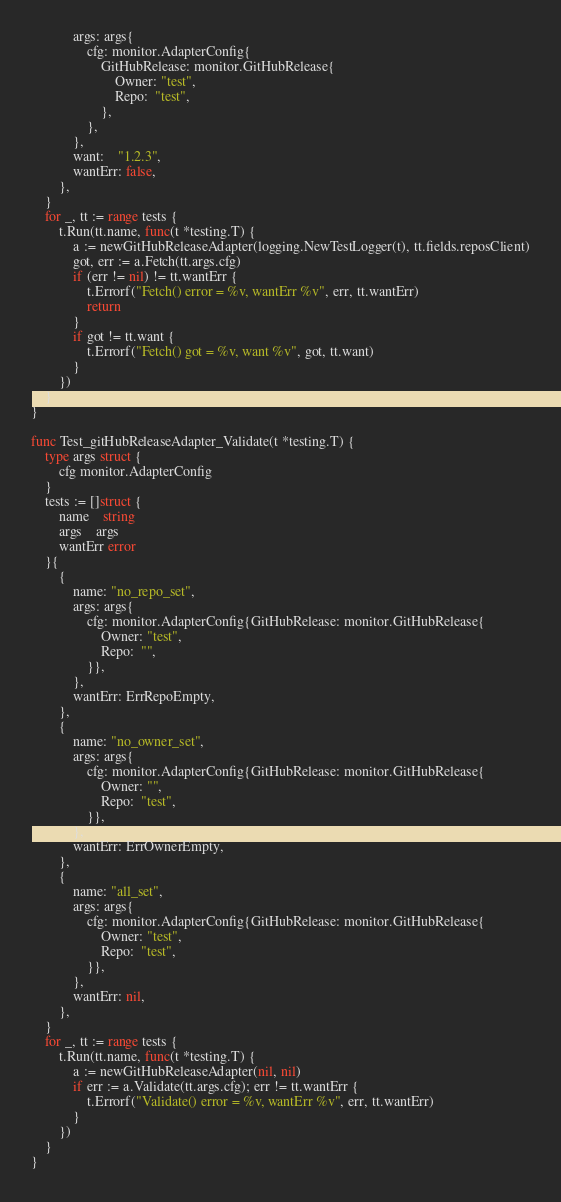<code> <loc_0><loc_0><loc_500><loc_500><_Go_>			args: args{
				cfg: monitor.AdapterConfig{
					GitHubRelease: monitor.GitHubRelease{
						Owner: "test",
						Repo:  "test",
					},
				},
			},
			want:    "1.2.3",
			wantErr: false,
		},
	}
	for _, tt := range tests {
		t.Run(tt.name, func(t *testing.T) {
			a := newGitHubReleaseAdapter(logging.NewTestLogger(t), tt.fields.reposClient)
			got, err := a.Fetch(tt.args.cfg)
			if (err != nil) != tt.wantErr {
				t.Errorf("Fetch() error = %v, wantErr %v", err, tt.wantErr)
				return
			}
			if got != tt.want {
				t.Errorf("Fetch() got = %v, want %v", got, tt.want)
			}
		})
	}
}

func Test_gitHubReleaseAdapter_Validate(t *testing.T) {
	type args struct {
		cfg monitor.AdapterConfig
	}
	tests := []struct {
		name    string
		args    args
		wantErr error
	}{
		{
			name: "no_repo_set",
			args: args{
				cfg: monitor.AdapterConfig{GitHubRelease: monitor.GitHubRelease{
					Owner: "test",
					Repo:  "",
				}},
			},
			wantErr: ErrRepoEmpty,
		},
		{
			name: "no_owner_set",
			args: args{
				cfg: monitor.AdapterConfig{GitHubRelease: monitor.GitHubRelease{
					Owner: "",
					Repo:  "test",
				}},
			},
			wantErr: ErrOwnerEmpty,
		},
		{
			name: "all_set",
			args: args{
				cfg: monitor.AdapterConfig{GitHubRelease: monitor.GitHubRelease{
					Owner: "test",
					Repo:  "test",
				}},
			},
			wantErr: nil,
		},
	}
	for _, tt := range tests {
		t.Run(tt.name, func(t *testing.T) {
			a := newGitHubReleaseAdapter(nil, nil)
			if err := a.Validate(tt.args.cfg); err != tt.wantErr {
				t.Errorf("Validate() error = %v, wantErr %v", err, tt.wantErr)
			}
		})
	}
}
</code> 